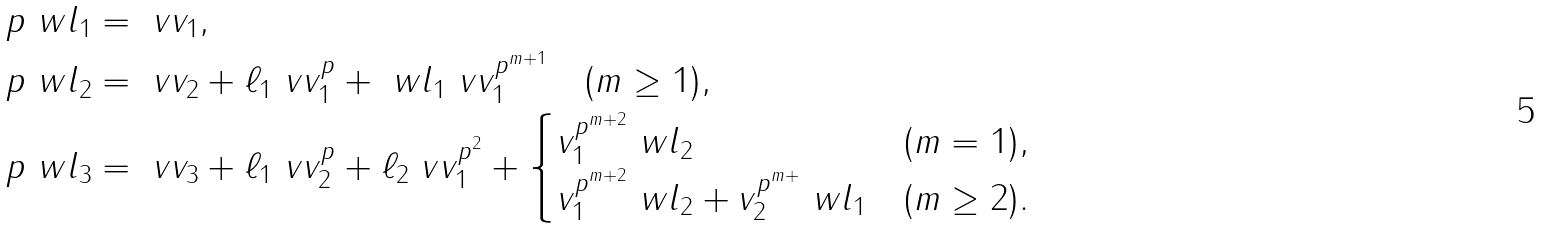<formula> <loc_0><loc_0><loc_500><loc_500>p \ w l _ { 1 } & = \ v v _ { 1 } , \\ \quad p \ w l _ { 2 } & = \ v v _ { 2 } + \ell _ { 1 } \ v v _ { 1 } ^ { p } + \ w l _ { 1 } \ v v _ { 1 } ^ { p ^ { m + 1 } } \quad ( m \geq 1 ) , \\ \quad p \ w l _ { 3 } & = \ v v _ { 3 } + \ell _ { 1 } \ v v _ { 2 } ^ { p } + \ell _ { 2 } \ v v _ { 1 } ^ { p ^ { 2 } } + \begin{cases} v _ { 1 } ^ { p ^ { m + 2 } } \ w l _ { 2 } & ( m = 1 ) , \\ v _ { 1 } ^ { p ^ { m + 2 } } \ w l _ { 2 } + v _ { 2 } ^ { p ^ { m + } } \ w l _ { 1 } & ( m \geq 2 ) . \end{cases}</formula> 